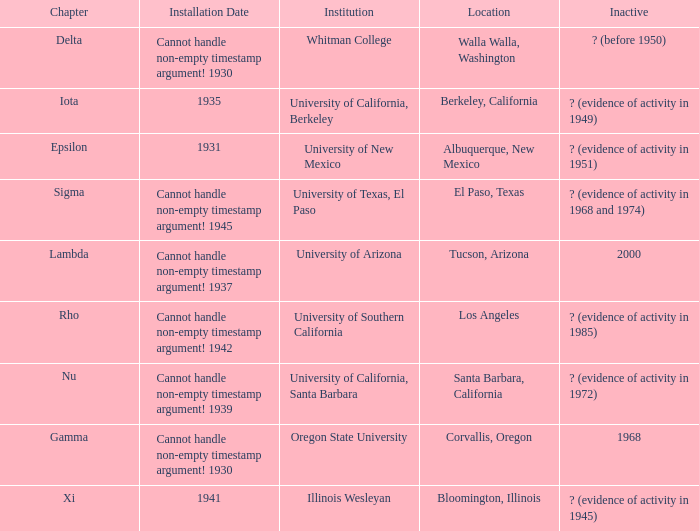What was the installation date in El Paso, Texas?  Cannot handle non-empty timestamp argument! 1945. 